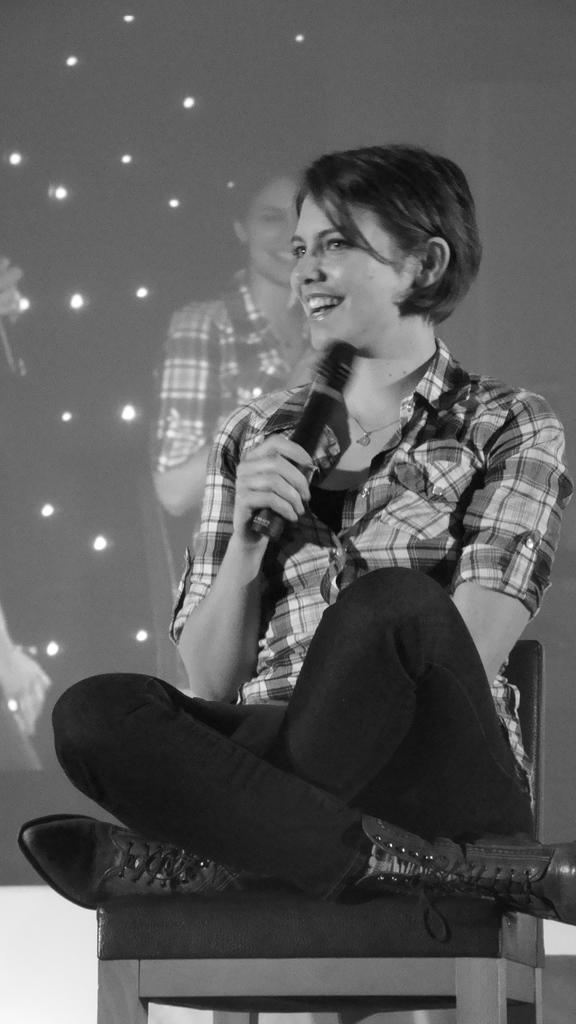Please provide a concise description of this image. This is a black and white image. In this image we can see there is a girl sitting on the chair and holding a mic in her hand. In the background there is a screen. On the screen we can see there are few lights and the girl sitting on the chair. 